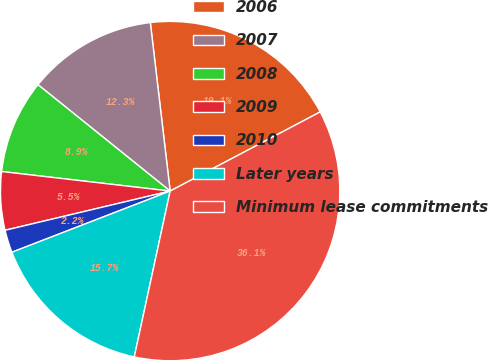<chart> <loc_0><loc_0><loc_500><loc_500><pie_chart><fcel>2006<fcel>2007<fcel>2008<fcel>2009<fcel>2010<fcel>Later years<fcel>Minimum lease commitments<nl><fcel>19.14%<fcel>12.35%<fcel>8.95%<fcel>5.55%<fcel>2.16%<fcel>15.74%<fcel>36.12%<nl></chart> 